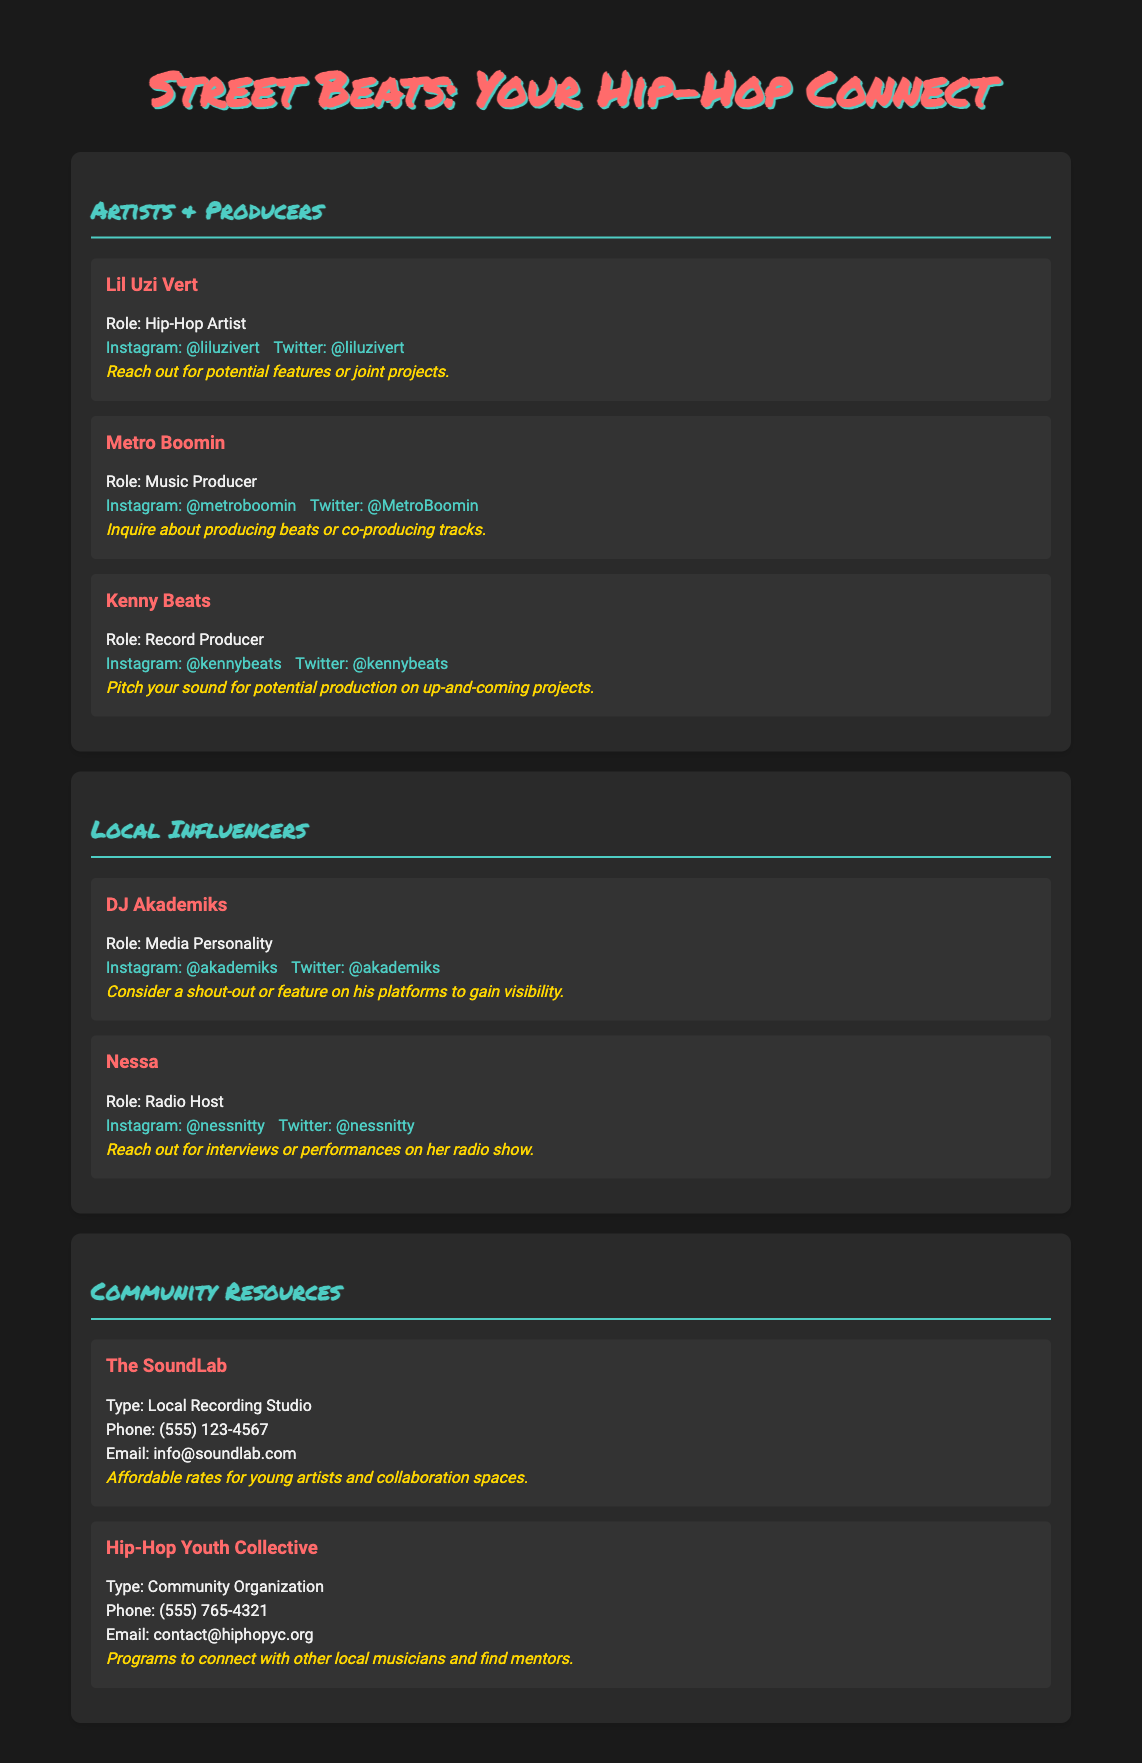what is the role of Lil Uzi Vert? Lil Uzi Vert is identified as a Hip-Hop Artist in the document.
Answer: Hip-Hop Artist how can you reach Metro Boomin? The document provides links to Metro Boomin's social media accounts, specifically Instagram and Twitter.
Answer: Instagram: @metroboomin, Twitter: @MetroBoomin who is the media personality mentioned in the document? The document lists DJ Akademiks as the media personality.
Answer: DJ Akademiks what type of organization is Hip-Hop Youth Collective? The document specifies that the Hip-Hop Youth Collective is a Community Organization.
Answer: Community Organization what is the phone number for The SoundLab? The document provides the phone number for The SoundLab as (555) 123-4567.
Answer: (555) 123-4567 what opportunity is mentioned for Kenny Beats? The document states that you can pitch your sound for potential production on up-and-coming projects.
Answer: Pitch your sound for potential production what is the role of Nessa? Nessa is identified as a Radio Host in the document.
Answer: Radio Host which social media platform can you find Kenny Beats on? The document indicates that Kenny Beats has accounts on Instagram and Twitter.
Answer: Instagram, Twitter 